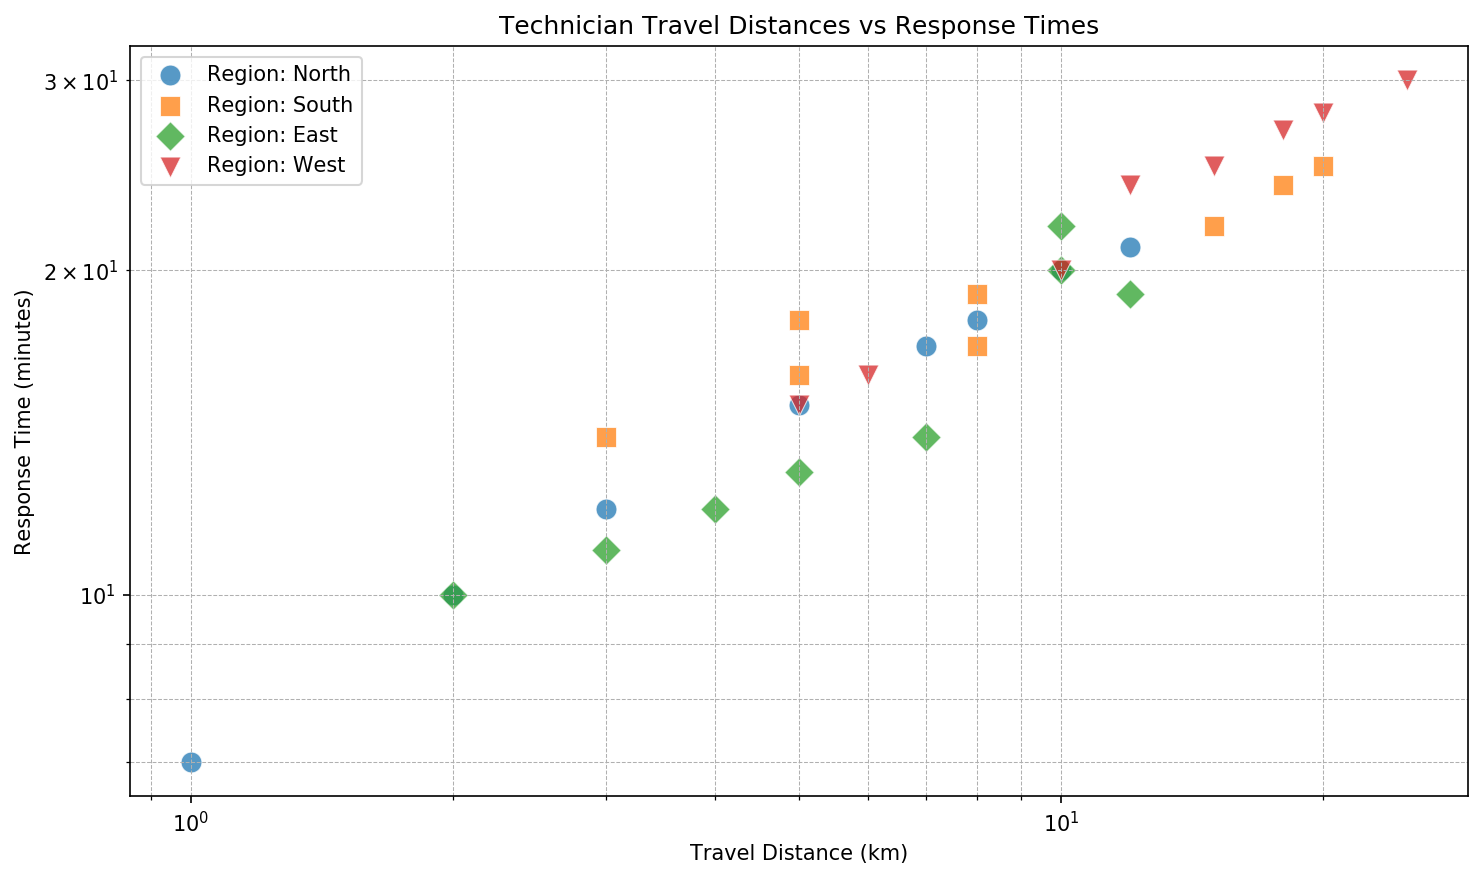What region has the highest response time for a travel distance of around 10 km? Look at the data points around the 10 km mark on the x-axis. The highest response time is in the West region with a response time of 20 minutes.
Answer: West How does the average response time for North compare to the East? Calculate the average response time for North and East separately. North: (15+20+10+18+12+21+17+7)/8 = 15.125 minutes, East: (14+19+11+20+13+22+10+12)/8 = 15.125 minutes. Both averages are equal.
Answer: Equal Which region has the greatest range in travel distances? Identify the maximum and minimum travel distances for each region and calculate the range. North: 12-1 = 11 km, South: 20-3 = 17 km, East: 12-2 = 10 km, West: 25-5 = 20 km. The West has the greatest range.
Answer: West Is there any region that shows a general trend of increasing response time with increasing travel distance? Analyze the scatter plots for each region to see if there is an upward trend in response time with increasing travel distance. The South and West regions show this trend.
Answer: South and West What is the travel distance for the technician with the least response time in the East region? Look for the point in East with the lowest y-value. The lowest response time is 10 minutes at a travel distance of 2 km.
Answer: 2 km Which region has the lowest median response time? Find the median of response times for each region. North: median of (7, 10, 12, 15, 17, 18, 20, 21) is 16.5 minutes, South: median of (14, 16, 17, 18, 19, 22, 24, 25) is 20.5 minutes, East: median of (10, 11, 12, 13, 14, 19, 20, 22) is 13.5 minutes, West: median of (15, 16, 20, 24, 25, 27, 28, 30) is 24.5 minutes. East has the lowest median response time.
Answer: East Between travel distances of 5 - 10 km, which region has the most variability in response times? Consider the spread of response times within the 5 - 10 km range for each region. North has response times of (12, 15, 17, 18, 20), South has (16, 17, 18, 19), East has (13, 14, 19, 20), West has (15, 16, 20). North shows the most variability.
Answer: North Are there any regions where technicians have travel distances over 15 km? Check if any data points exceed 15 km on the x-axis and identify the regions. Only the South and West regions have such travel distances.
Answer: South and West What is the maximum response time recorded for technicians in the North region? Identify the highest y-value in the North region. The maximum response time recorded is 21 minutes.
Answer: 21 minutes 